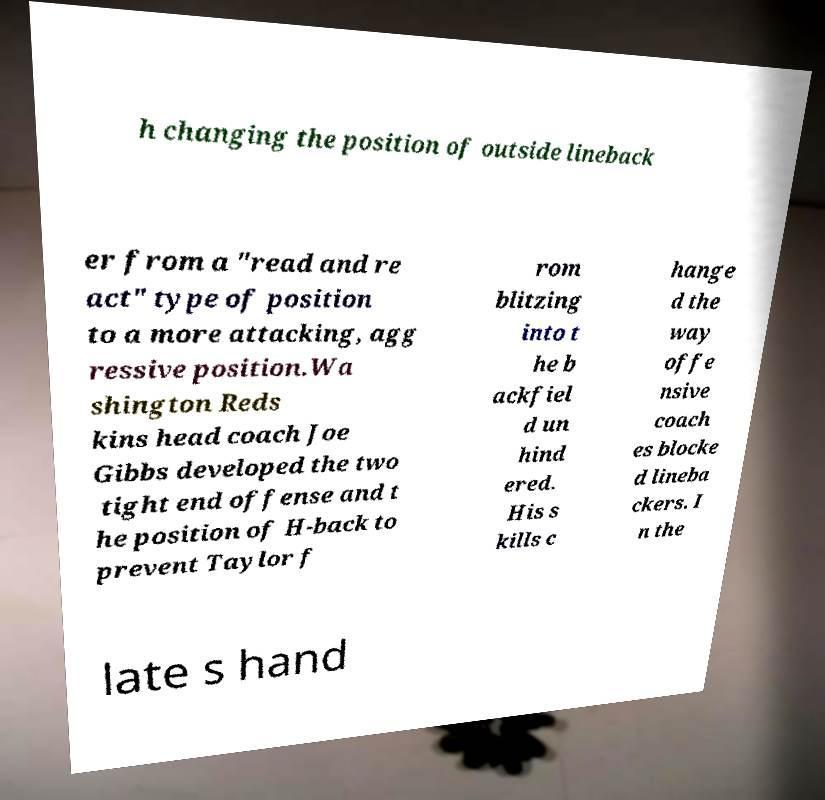Can you accurately transcribe the text from the provided image for me? h changing the position of outside lineback er from a "read and re act" type of position to a more attacking, agg ressive position.Wa shington Reds kins head coach Joe Gibbs developed the two tight end offense and t he position of H-back to prevent Taylor f rom blitzing into t he b ackfiel d un hind ered. His s kills c hange d the way offe nsive coach es blocke d lineba ckers. I n the late s hand 